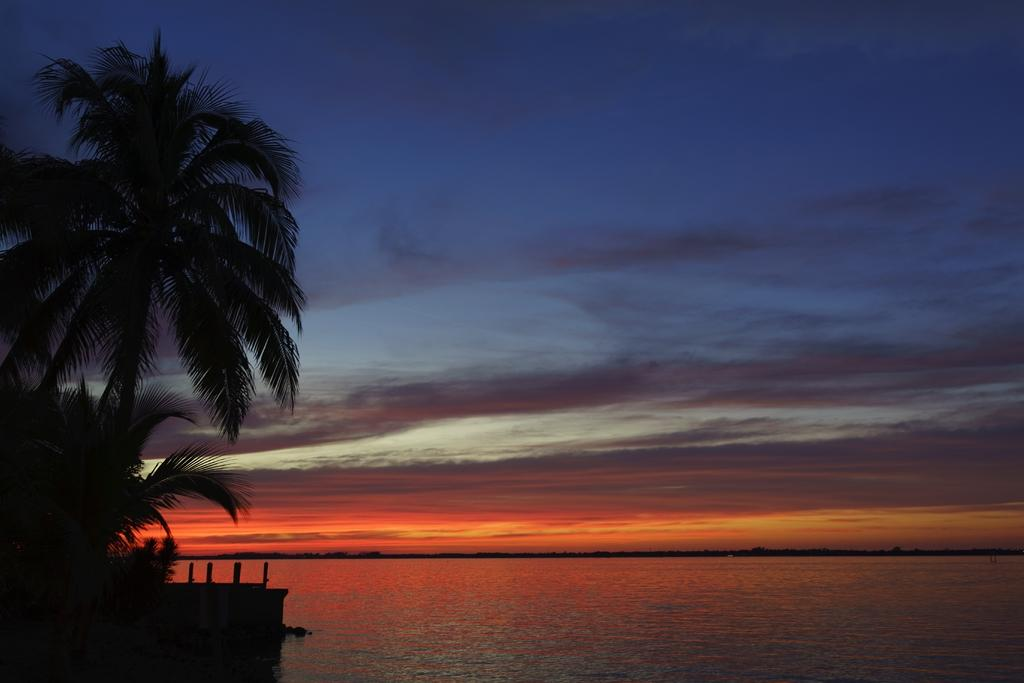What is visible in the image? There is water, coconut trees, and the sky visible in the image. Can you describe the water in the image? The water is visible, but its depth or any specific features are not mentioned in the facts. What type of vegetation is present in the image? Coconut trees are present in the image. What part of the natural environment is visible in the image? The sky is visible in the image. How many beads are hanging from the coconut trees in the image? There is no mention of beads in the image, so it is impossible to determine their presence or quantity. 